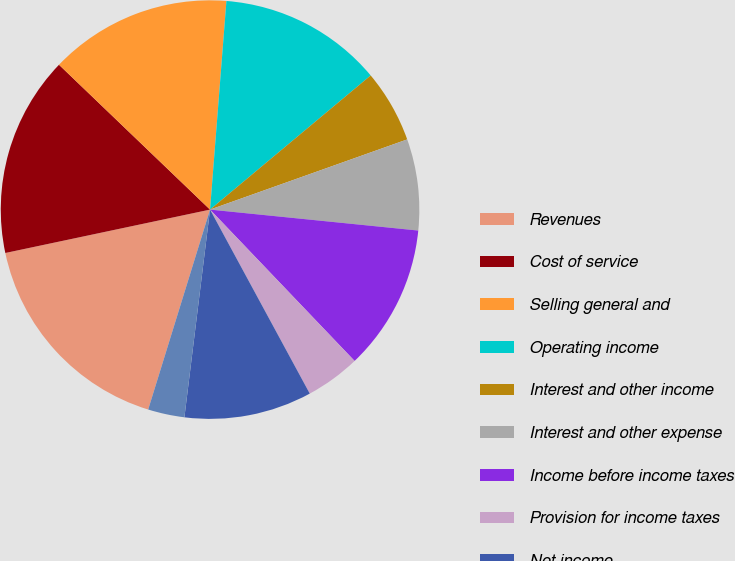<chart> <loc_0><loc_0><loc_500><loc_500><pie_chart><fcel>Revenues<fcel>Cost of service<fcel>Selling general and<fcel>Operating income<fcel>Interest and other income<fcel>Interest and other expense<fcel>Income before income taxes<fcel>Provision for income taxes<fcel>Net income<fcel>Less Net income attributable<nl><fcel>16.9%<fcel>15.49%<fcel>14.08%<fcel>12.68%<fcel>5.63%<fcel>7.04%<fcel>11.27%<fcel>4.23%<fcel>9.86%<fcel>2.82%<nl></chart> 